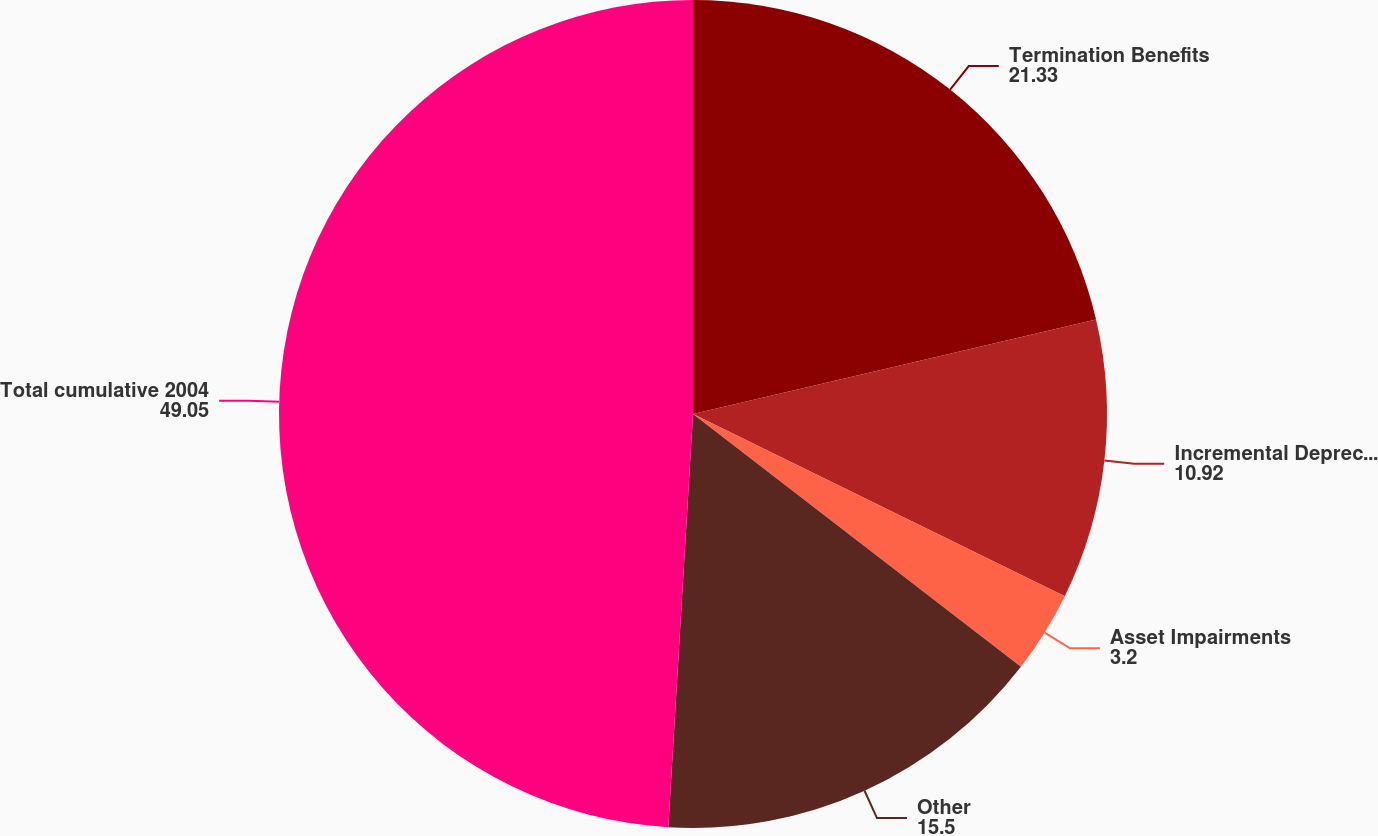Convert chart to OTSL. <chart><loc_0><loc_0><loc_500><loc_500><pie_chart><fcel>Termination Benefits<fcel>Incremental Depreciation<fcel>Asset Impairments<fcel>Other<fcel>Total cumulative 2004<nl><fcel>21.33%<fcel>10.92%<fcel>3.2%<fcel>15.5%<fcel>49.05%<nl></chart> 